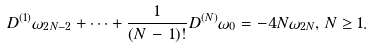Convert formula to latex. <formula><loc_0><loc_0><loc_500><loc_500>D ^ { ( 1 ) } \omega _ { 2 N - 2 } + \cdots + \frac { 1 } { ( N \, - \, 1 ) ! } D ^ { ( N ) } \omega _ { 0 } = - 4 N \omega _ { 2 N } , \, N \geq 1 .</formula> 